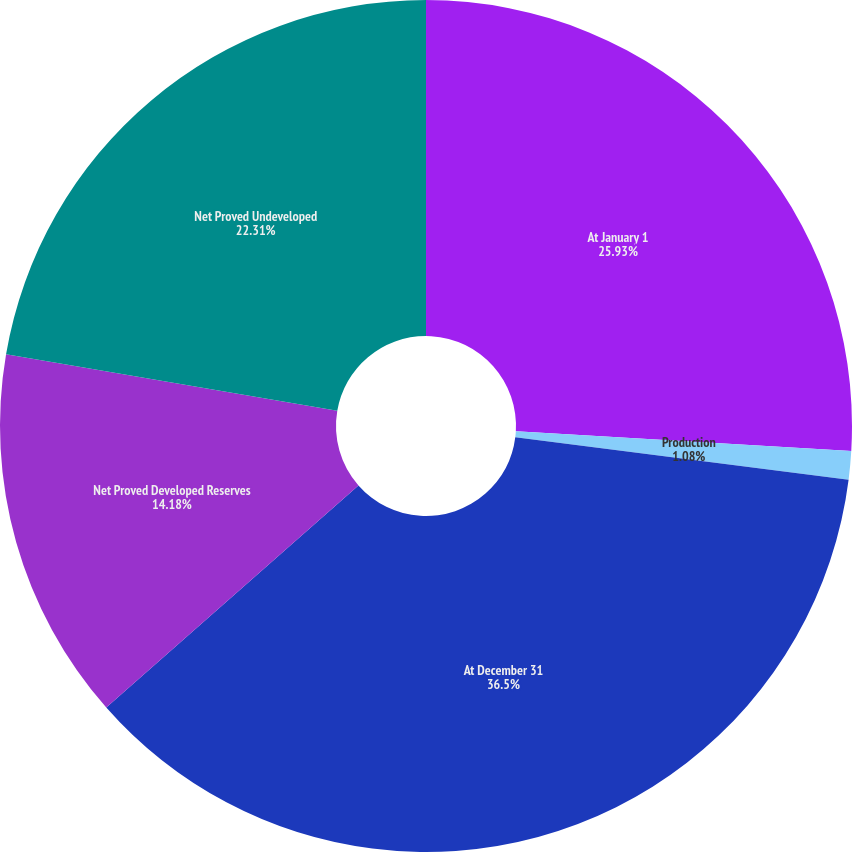<chart> <loc_0><loc_0><loc_500><loc_500><pie_chart><fcel>At January 1<fcel>Production<fcel>At December 31<fcel>Net Proved Developed Reserves<fcel>Net Proved Undeveloped<nl><fcel>25.93%<fcel>1.08%<fcel>36.5%<fcel>14.18%<fcel>22.31%<nl></chart> 